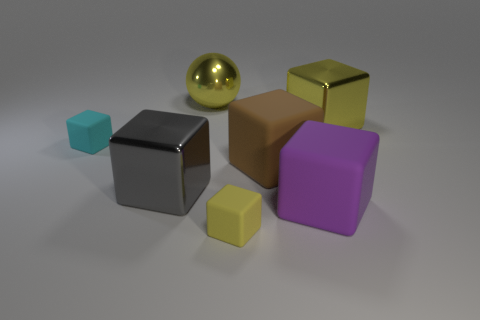What number of other things are made of the same material as the big brown block?
Your answer should be compact. 3. There is a shiny object in front of the brown object; what size is it?
Offer a very short reply. Large. What number of large things are either brown matte things or yellow rubber things?
Offer a terse response. 1. There is a big brown thing; are there any tiny yellow rubber objects left of it?
Give a very brief answer. Yes. What is the size of the matte object that is in front of the big matte object that is on the right side of the big brown block?
Ensure brevity in your answer.  Small. Are there an equal number of yellow cubes that are left of the tiny cyan matte block and large yellow balls right of the large yellow metal ball?
Provide a short and direct response. Yes. There is a yellow cube that is on the right side of the big brown cube; are there any small rubber cubes on the right side of it?
Ensure brevity in your answer.  No. There is a large yellow shiny object that is left of the yellow block behind the large purple rubber cube; how many big yellow metallic objects are in front of it?
Give a very brief answer. 1. Is the number of cyan rubber objects less than the number of large blue matte objects?
Your response must be concise. No. Is the shape of the tiny object behind the big gray cube the same as the big matte thing that is on the right side of the brown matte object?
Provide a short and direct response. Yes. 